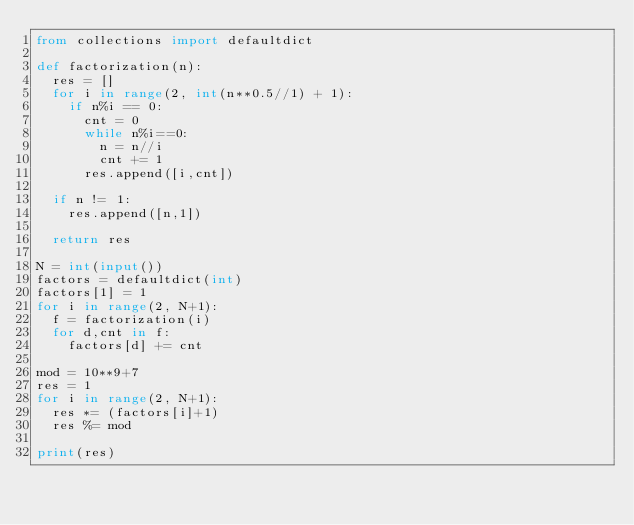Convert code to text. <code><loc_0><loc_0><loc_500><loc_500><_Python_>from collections import defaultdict

def factorization(n):
  res = []
  for i in range(2, int(n**0.5//1) + 1):
    if n%i == 0:
      cnt = 0
      while n%i==0:
        n = n//i
        cnt += 1
      res.append([i,cnt])

  if n != 1:
    res.append([n,1])

  return res

N = int(input())
factors = defaultdict(int)
factors[1] = 1
for i in range(2, N+1):
  f = factorization(i)
  for d,cnt in f:
    factors[d] += cnt

mod = 10**9+7
res = 1
for i in range(2, N+1):
  res *= (factors[i]+1)
  res %= mod

print(res)</code> 